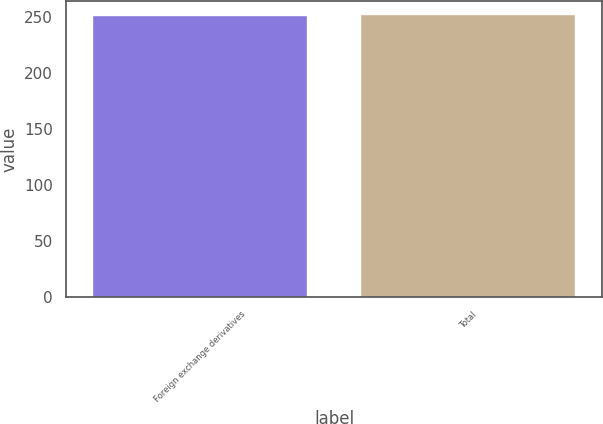<chart> <loc_0><loc_0><loc_500><loc_500><bar_chart><fcel>Foreign exchange derivatives<fcel>Total<nl><fcel>251<fcel>251.1<nl></chart> 